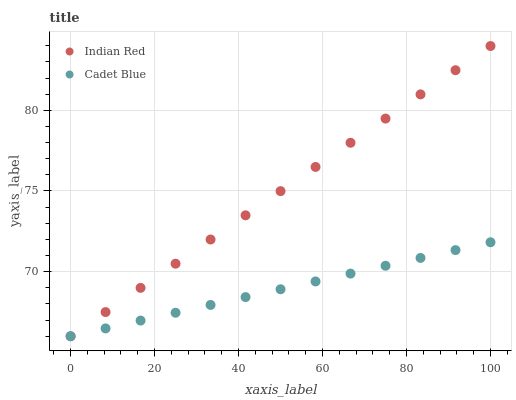Does Cadet Blue have the minimum area under the curve?
Answer yes or no. Yes. Does Indian Red have the maximum area under the curve?
Answer yes or no. Yes. Does Indian Red have the minimum area under the curve?
Answer yes or no. No. Is Cadet Blue the smoothest?
Answer yes or no. Yes. Is Indian Red the roughest?
Answer yes or no. Yes. Is Indian Red the smoothest?
Answer yes or no. No. Does Cadet Blue have the lowest value?
Answer yes or no. Yes. Does Indian Red have the highest value?
Answer yes or no. Yes. Does Cadet Blue intersect Indian Red?
Answer yes or no. Yes. Is Cadet Blue less than Indian Red?
Answer yes or no. No. Is Cadet Blue greater than Indian Red?
Answer yes or no. No. 